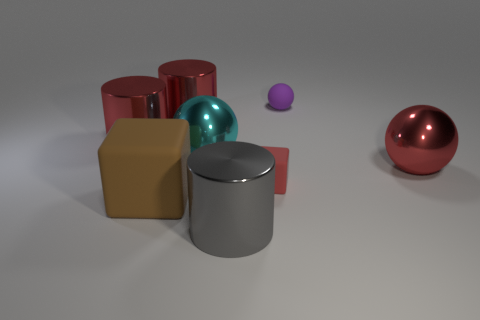Add 1 purple objects. How many objects exist? 9 Subtract all balls. How many objects are left? 5 Add 3 big purple shiny cylinders. How many big purple shiny cylinders exist? 3 Subtract 0 blue cubes. How many objects are left? 8 Subtract all small purple matte balls. Subtract all large things. How many objects are left? 1 Add 4 big cylinders. How many big cylinders are left? 7 